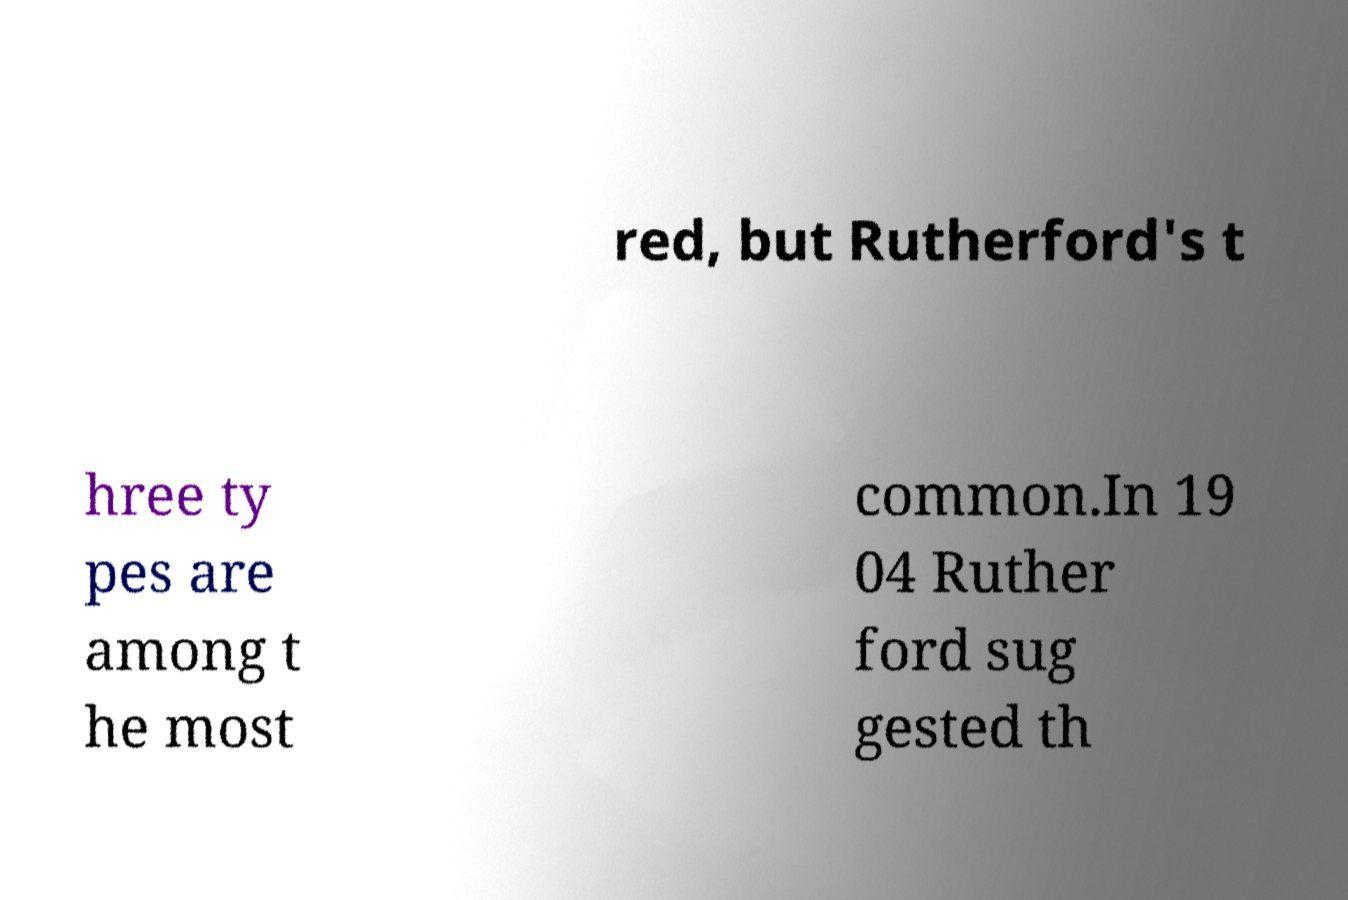There's text embedded in this image that I need extracted. Can you transcribe it verbatim? red, but Rutherford's t hree ty pes are among t he most common.In 19 04 Ruther ford sug gested th 